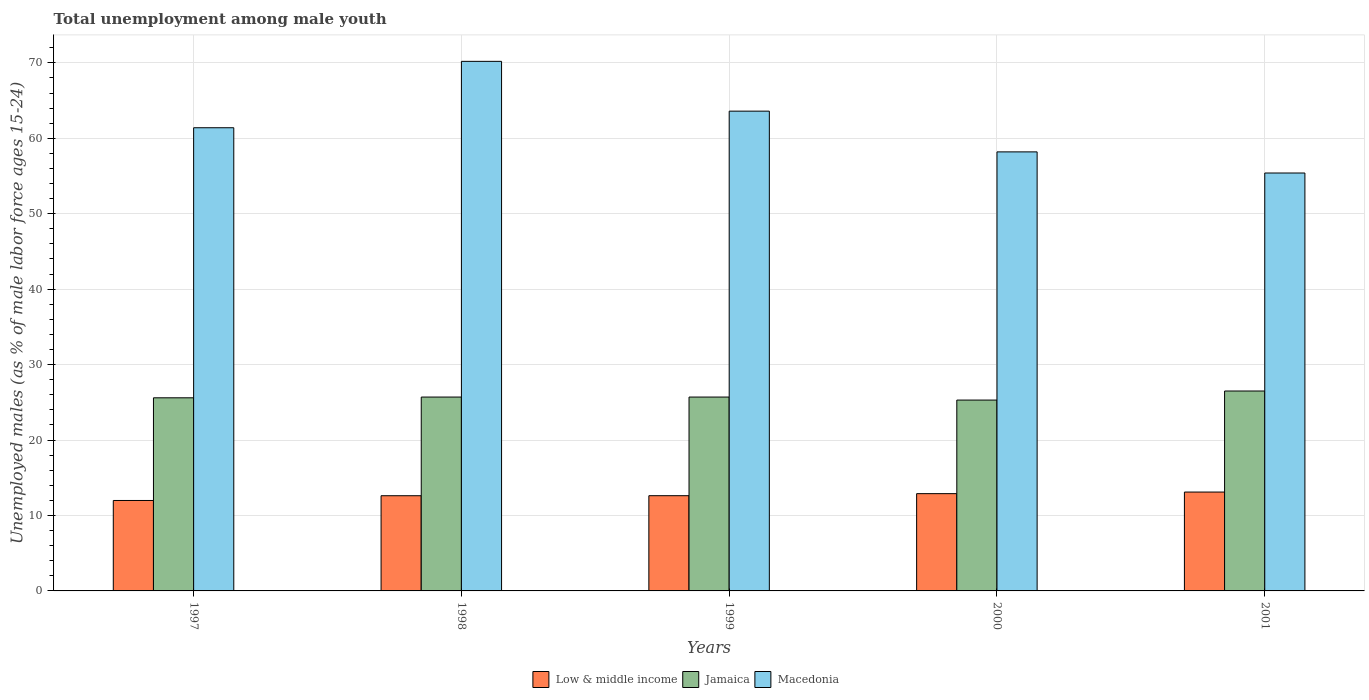How many groups of bars are there?
Keep it short and to the point. 5. Are the number of bars per tick equal to the number of legend labels?
Offer a very short reply. Yes. Are the number of bars on each tick of the X-axis equal?
Provide a short and direct response. Yes. How many bars are there on the 1st tick from the right?
Keep it short and to the point. 3. What is the label of the 3rd group of bars from the left?
Ensure brevity in your answer.  1999. What is the percentage of unemployed males in in Jamaica in 1998?
Your answer should be compact. 25.7. Across all years, what is the maximum percentage of unemployed males in in Low & middle income?
Your answer should be very brief. 13.11. Across all years, what is the minimum percentage of unemployed males in in Macedonia?
Make the answer very short. 55.4. In which year was the percentage of unemployed males in in Jamaica maximum?
Make the answer very short. 2001. What is the total percentage of unemployed males in in Low & middle income in the graph?
Your answer should be compact. 63.23. What is the difference between the percentage of unemployed males in in Low & middle income in 1999 and that in 2001?
Make the answer very short. -0.48. What is the difference between the percentage of unemployed males in in Jamaica in 1997 and the percentage of unemployed males in in Low & middle income in 1999?
Your response must be concise. 12.98. What is the average percentage of unemployed males in in Macedonia per year?
Your answer should be compact. 61.76. In the year 2001, what is the difference between the percentage of unemployed males in in Macedonia and percentage of unemployed males in in Low & middle income?
Offer a terse response. 42.29. What is the ratio of the percentage of unemployed males in in Low & middle income in 1999 to that in 2000?
Make the answer very short. 0.98. Is the percentage of unemployed males in in Low & middle income in 1999 less than that in 2000?
Your response must be concise. Yes. Is the difference between the percentage of unemployed males in in Macedonia in 1999 and 2001 greater than the difference between the percentage of unemployed males in in Low & middle income in 1999 and 2001?
Provide a short and direct response. Yes. What is the difference between the highest and the second highest percentage of unemployed males in in Jamaica?
Give a very brief answer. 0.8. What is the difference between the highest and the lowest percentage of unemployed males in in Low & middle income?
Your answer should be very brief. 1.12. In how many years, is the percentage of unemployed males in in Macedonia greater than the average percentage of unemployed males in in Macedonia taken over all years?
Keep it short and to the point. 2. Is the sum of the percentage of unemployed males in in Macedonia in 1999 and 2001 greater than the maximum percentage of unemployed males in in Jamaica across all years?
Offer a terse response. Yes. What does the 2nd bar from the left in 2001 represents?
Offer a very short reply. Jamaica. What does the 3rd bar from the right in 2000 represents?
Your answer should be very brief. Low & middle income. How many bars are there?
Provide a succinct answer. 15. What is the difference between two consecutive major ticks on the Y-axis?
Make the answer very short. 10. Are the values on the major ticks of Y-axis written in scientific E-notation?
Keep it short and to the point. No. Does the graph contain grids?
Ensure brevity in your answer.  Yes. How many legend labels are there?
Give a very brief answer. 3. What is the title of the graph?
Offer a terse response. Total unemployment among male youth. Does "New Caledonia" appear as one of the legend labels in the graph?
Your answer should be compact. No. What is the label or title of the X-axis?
Provide a short and direct response. Years. What is the label or title of the Y-axis?
Provide a succinct answer. Unemployed males (as % of male labor force ages 15-24). What is the Unemployed males (as % of male labor force ages 15-24) of Low & middle income in 1997?
Give a very brief answer. 11.99. What is the Unemployed males (as % of male labor force ages 15-24) of Jamaica in 1997?
Offer a very short reply. 25.6. What is the Unemployed males (as % of male labor force ages 15-24) of Macedonia in 1997?
Your response must be concise. 61.4. What is the Unemployed males (as % of male labor force ages 15-24) of Low & middle income in 1998?
Give a very brief answer. 12.62. What is the Unemployed males (as % of male labor force ages 15-24) in Jamaica in 1998?
Keep it short and to the point. 25.7. What is the Unemployed males (as % of male labor force ages 15-24) in Macedonia in 1998?
Offer a terse response. 70.2. What is the Unemployed males (as % of male labor force ages 15-24) of Low & middle income in 1999?
Ensure brevity in your answer.  12.62. What is the Unemployed males (as % of male labor force ages 15-24) of Jamaica in 1999?
Offer a very short reply. 25.7. What is the Unemployed males (as % of male labor force ages 15-24) of Macedonia in 1999?
Ensure brevity in your answer.  63.6. What is the Unemployed males (as % of male labor force ages 15-24) of Low & middle income in 2000?
Your answer should be compact. 12.9. What is the Unemployed males (as % of male labor force ages 15-24) of Jamaica in 2000?
Provide a succinct answer. 25.3. What is the Unemployed males (as % of male labor force ages 15-24) in Macedonia in 2000?
Give a very brief answer. 58.2. What is the Unemployed males (as % of male labor force ages 15-24) of Low & middle income in 2001?
Provide a succinct answer. 13.11. What is the Unemployed males (as % of male labor force ages 15-24) of Jamaica in 2001?
Offer a terse response. 26.5. What is the Unemployed males (as % of male labor force ages 15-24) of Macedonia in 2001?
Ensure brevity in your answer.  55.4. Across all years, what is the maximum Unemployed males (as % of male labor force ages 15-24) in Low & middle income?
Offer a terse response. 13.11. Across all years, what is the maximum Unemployed males (as % of male labor force ages 15-24) in Macedonia?
Your answer should be compact. 70.2. Across all years, what is the minimum Unemployed males (as % of male labor force ages 15-24) in Low & middle income?
Your answer should be very brief. 11.99. Across all years, what is the minimum Unemployed males (as % of male labor force ages 15-24) in Jamaica?
Make the answer very short. 25.3. Across all years, what is the minimum Unemployed males (as % of male labor force ages 15-24) of Macedonia?
Keep it short and to the point. 55.4. What is the total Unemployed males (as % of male labor force ages 15-24) of Low & middle income in the graph?
Offer a very short reply. 63.23. What is the total Unemployed males (as % of male labor force ages 15-24) in Jamaica in the graph?
Your response must be concise. 128.8. What is the total Unemployed males (as % of male labor force ages 15-24) of Macedonia in the graph?
Your answer should be compact. 308.8. What is the difference between the Unemployed males (as % of male labor force ages 15-24) of Low & middle income in 1997 and that in 1998?
Provide a short and direct response. -0.63. What is the difference between the Unemployed males (as % of male labor force ages 15-24) in Jamaica in 1997 and that in 1998?
Give a very brief answer. -0.1. What is the difference between the Unemployed males (as % of male labor force ages 15-24) in Macedonia in 1997 and that in 1998?
Your answer should be compact. -8.8. What is the difference between the Unemployed males (as % of male labor force ages 15-24) of Low & middle income in 1997 and that in 1999?
Offer a terse response. -0.63. What is the difference between the Unemployed males (as % of male labor force ages 15-24) in Macedonia in 1997 and that in 1999?
Your answer should be very brief. -2.2. What is the difference between the Unemployed males (as % of male labor force ages 15-24) in Low & middle income in 1997 and that in 2000?
Your answer should be very brief. -0.91. What is the difference between the Unemployed males (as % of male labor force ages 15-24) of Jamaica in 1997 and that in 2000?
Provide a succinct answer. 0.3. What is the difference between the Unemployed males (as % of male labor force ages 15-24) in Low & middle income in 1997 and that in 2001?
Offer a terse response. -1.12. What is the difference between the Unemployed males (as % of male labor force ages 15-24) of Low & middle income in 1998 and that in 1999?
Your response must be concise. -0. What is the difference between the Unemployed males (as % of male labor force ages 15-24) in Jamaica in 1998 and that in 1999?
Make the answer very short. 0. What is the difference between the Unemployed males (as % of male labor force ages 15-24) in Macedonia in 1998 and that in 1999?
Keep it short and to the point. 6.6. What is the difference between the Unemployed males (as % of male labor force ages 15-24) of Low & middle income in 1998 and that in 2000?
Provide a succinct answer. -0.28. What is the difference between the Unemployed males (as % of male labor force ages 15-24) in Low & middle income in 1998 and that in 2001?
Ensure brevity in your answer.  -0.49. What is the difference between the Unemployed males (as % of male labor force ages 15-24) of Jamaica in 1998 and that in 2001?
Your response must be concise. -0.8. What is the difference between the Unemployed males (as % of male labor force ages 15-24) of Low & middle income in 1999 and that in 2000?
Give a very brief answer. -0.27. What is the difference between the Unemployed males (as % of male labor force ages 15-24) in Macedonia in 1999 and that in 2000?
Offer a very short reply. 5.4. What is the difference between the Unemployed males (as % of male labor force ages 15-24) of Low & middle income in 1999 and that in 2001?
Provide a short and direct response. -0.48. What is the difference between the Unemployed males (as % of male labor force ages 15-24) of Macedonia in 1999 and that in 2001?
Offer a very short reply. 8.2. What is the difference between the Unemployed males (as % of male labor force ages 15-24) in Low & middle income in 2000 and that in 2001?
Keep it short and to the point. -0.21. What is the difference between the Unemployed males (as % of male labor force ages 15-24) of Low & middle income in 1997 and the Unemployed males (as % of male labor force ages 15-24) of Jamaica in 1998?
Your response must be concise. -13.71. What is the difference between the Unemployed males (as % of male labor force ages 15-24) in Low & middle income in 1997 and the Unemployed males (as % of male labor force ages 15-24) in Macedonia in 1998?
Offer a very short reply. -58.21. What is the difference between the Unemployed males (as % of male labor force ages 15-24) of Jamaica in 1997 and the Unemployed males (as % of male labor force ages 15-24) of Macedonia in 1998?
Offer a terse response. -44.6. What is the difference between the Unemployed males (as % of male labor force ages 15-24) in Low & middle income in 1997 and the Unemployed males (as % of male labor force ages 15-24) in Jamaica in 1999?
Your response must be concise. -13.71. What is the difference between the Unemployed males (as % of male labor force ages 15-24) in Low & middle income in 1997 and the Unemployed males (as % of male labor force ages 15-24) in Macedonia in 1999?
Ensure brevity in your answer.  -51.61. What is the difference between the Unemployed males (as % of male labor force ages 15-24) of Jamaica in 1997 and the Unemployed males (as % of male labor force ages 15-24) of Macedonia in 1999?
Provide a succinct answer. -38. What is the difference between the Unemployed males (as % of male labor force ages 15-24) of Low & middle income in 1997 and the Unemployed males (as % of male labor force ages 15-24) of Jamaica in 2000?
Your response must be concise. -13.31. What is the difference between the Unemployed males (as % of male labor force ages 15-24) in Low & middle income in 1997 and the Unemployed males (as % of male labor force ages 15-24) in Macedonia in 2000?
Give a very brief answer. -46.21. What is the difference between the Unemployed males (as % of male labor force ages 15-24) of Jamaica in 1997 and the Unemployed males (as % of male labor force ages 15-24) of Macedonia in 2000?
Provide a short and direct response. -32.6. What is the difference between the Unemployed males (as % of male labor force ages 15-24) of Low & middle income in 1997 and the Unemployed males (as % of male labor force ages 15-24) of Jamaica in 2001?
Make the answer very short. -14.51. What is the difference between the Unemployed males (as % of male labor force ages 15-24) of Low & middle income in 1997 and the Unemployed males (as % of male labor force ages 15-24) of Macedonia in 2001?
Provide a succinct answer. -43.41. What is the difference between the Unemployed males (as % of male labor force ages 15-24) in Jamaica in 1997 and the Unemployed males (as % of male labor force ages 15-24) in Macedonia in 2001?
Offer a very short reply. -29.8. What is the difference between the Unemployed males (as % of male labor force ages 15-24) in Low & middle income in 1998 and the Unemployed males (as % of male labor force ages 15-24) in Jamaica in 1999?
Your answer should be very brief. -13.08. What is the difference between the Unemployed males (as % of male labor force ages 15-24) in Low & middle income in 1998 and the Unemployed males (as % of male labor force ages 15-24) in Macedonia in 1999?
Provide a short and direct response. -50.98. What is the difference between the Unemployed males (as % of male labor force ages 15-24) in Jamaica in 1998 and the Unemployed males (as % of male labor force ages 15-24) in Macedonia in 1999?
Provide a succinct answer. -37.9. What is the difference between the Unemployed males (as % of male labor force ages 15-24) of Low & middle income in 1998 and the Unemployed males (as % of male labor force ages 15-24) of Jamaica in 2000?
Give a very brief answer. -12.68. What is the difference between the Unemployed males (as % of male labor force ages 15-24) in Low & middle income in 1998 and the Unemployed males (as % of male labor force ages 15-24) in Macedonia in 2000?
Your response must be concise. -45.58. What is the difference between the Unemployed males (as % of male labor force ages 15-24) of Jamaica in 1998 and the Unemployed males (as % of male labor force ages 15-24) of Macedonia in 2000?
Ensure brevity in your answer.  -32.5. What is the difference between the Unemployed males (as % of male labor force ages 15-24) in Low & middle income in 1998 and the Unemployed males (as % of male labor force ages 15-24) in Jamaica in 2001?
Ensure brevity in your answer.  -13.88. What is the difference between the Unemployed males (as % of male labor force ages 15-24) in Low & middle income in 1998 and the Unemployed males (as % of male labor force ages 15-24) in Macedonia in 2001?
Provide a succinct answer. -42.78. What is the difference between the Unemployed males (as % of male labor force ages 15-24) of Jamaica in 1998 and the Unemployed males (as % of male labor force ages 15-24) of Macedonia in 2001?
Offer a very short reply. -29.7. What is the difference between the Unemployed males (as % of male labor force ages 15-24) of Low & middle income in 1999 and the Unemployed males (as % of male labor force ages 15-24) of Jamaica in 2000?
Your answer should be very brief. -12.68. What is the difference between the Unemployed males (as % of male labor force ages 15-24) of Low & middle income in 1999 and the Unemployed males (as % of male labor force ages 15-24) of Macedonia in 2000?
Provide a short and direct response. -45.58. What is the difference between the Unemployed males (as % of male labor force ages 15-24) of Jamaica in 1999 and the Unemployed males (as % of male labor force ages 15-24) of Macedonia in 2000?
Provide a succinct answer. -32.5. What is the difference between the Unemployed males (as % of male labor force ages 15-24) of Low & middle income in 1999 and the Unemployed males (as % of male labor force ages 15-24) of Jamaica in 2001?
Keep it short and to the point. -13.88. What is the difference between the Unemployed males (as % of male labor force ages 15-24) in Low & middle income in 1999 and the Unemployed males (as % of male labor force ages 15-24) in Macedonia in 2001?
Offer a terse response. -42.78. What is the difference between the Unemployed males (as % of male labor force ages 15-24) of Jamaica in 1999 and the Unemployed males (as % of male labor force ages 15-24) of Macedonia in 2001?
Provide a short and direct response. -29.7. What is the difference between the Unemployed males (as % of male labor force ages 15-24) in Low & middle income in 2000 and the Unemployed males (as % of male labor force ages 15-24) in Jamaica in 2001?
Your response must be concise. -13.6. What is the difference between the Unemployed males (as % of male labor force ages 15-24) in Low & middle income in 2000 and the Unemployed males (as % of male labor force ages 15-24) in Macedonia in 2001?
Give a very brief answer. -42.5. What is the difference between the Unemployed males (as % of male labor force ages 15-24) of Jamaica in 2000 and the Unemployed males (as % of male labor force ages 15-24) of Macedonia in 2001?
Provide a succinct answer. -30.1. What is the average Unemployed males (as % of male labor force ages 15-24) in Low & middle income per year?
Keep it short and to the point. 12.65. What is the average Unemployed males (as % of male labor force ages 15-24) in Jamaica per year?
Provide a succinct answer. 25.76. What is the average Unemployed males (as % of male labor force ages 15-24) of Macedonia per year?
Provide a short and direct response. 61.76. In the year 1997, what is the difference between the Unemployed males (as % of male labor force ages 15-24) of Low & middle income and Unemployed males (as % of male labor force ages 15-24) of Jamaica?
Offer a terse response. -13.61. In the year 1997, what is the difference between the Unemployed males (as % of male labor force ages 15-24) in Low & middle income and Unemployed males (as % of male labor force ages 15-24) in Macedonia?
Ensure brevity in your answer.  -49.41. In the year 1997, what is the difference between the Unemployed males (as % of male labor force ages 15-24) in Jamaica and Unemployed males (as % of male labor force ages 15-24) in Macedonia?
Keep it short and to the point. -35.8. In the year 1998, what is the difference between the Unemployed males (as % of male labor force ages 15-24) of Low & middle income and Unemployed males (as % of male labor force ages 15-24) of Jamaica?
Offer a very short reply. -13.08. In the year 1998, what is the difference between the Unemployed males (as % of male labor force ages 15-24) in Low & middle income and Unemployed males (as % of male labor force ages 15-24) in Macedonia?
Offer a very short reply. -57.58. In the year 1998, what is the difference between the Unemployed males (as % of male labor force ages 15-24) in Jamaica and Unemployed males (as % of male labor force ages 15-24) in Macedonia?
Your response must be concise. -44.5. In the year 1999, what is the difference between the Unemployed males (as % of male labor force ages 15-24) in Low & middle income and Unemployed males (as % of male labor force ages 15-24) in Jamaica?
Keep it short and to the point. -13.08. In the year 1999, what is the difference between the Unemployed males (as % of male labor force ages 15-24) in Low & middle income and Unemployed males (as % of male labor force ages 15-24) in Macedonia?
Give a very brief answer. -50.98. In the year 1999, what is the difference between the Unemployed males (as % of male labor force ages 15-24) in Jamaica and Unemployed males (as % of male labor force ages 15-24) in Macedonia?
Offer a terse response. -37.9. In the year 2000, what is the difference between the Unemployed males (as % of male labor force ages 15-24) in Low & middle income and Unemployed males (as % of male labor force ages 15-24) in Jamaica?
Provide a succinct answer. -12.4. In the year 2000, what is the difference between the Unemployed males (as % of male labor force ages 15-24) in Low & middle income and Unemployed males (as % of male labor force ages 15-24) in Macedonia?
Offer a terse response. -45.3. In the year 2000, what is the difference between the Unemployed males (as % of male labor force ages 15-24) in Jamaica and Unemployed males (as % of male labor force ages 15-24) in Macedonia?
Provide a succinct answer. -32.9. In the year 2001, what is the difference between the Unemployed males (as % of male labor force ages 15-24) of Low & middle income and Unemployed males (as % of male labor force ages 15-24) of Jamaica?
Provide a short and direct response. -13.39. In the year 2001, what is the difference between the Unemployed males (as % of male labor force ages 15-24) of Low & middle income and Unemployed males (as % of male labor force ages 15-24) of Macedonia?
Give a very brief answer. -42.29. In the year 2001, what is the difference between the Unemployed males (as % of male labor force ages 15-24) in Jamaica and Unemployed males (as % of male labor force ages 15-24) in Macedonia?
Provide a short and direct response. -28.9. What is the ratio of the Unemployed males (as % of male labor force ages 15-24) in Low & middle income in 1997 to that in 1998?
Your answer should be compact. 0.95. What is the ratio of the Unemployed males (as % of male labor force ages 15-24) of Jamaica in 1997 to that in 1998?
Ensure brevity in your answer.  1. What is the ratio of the Unemployed males (as % of male labor force ages 15-24) of Macedonia in 1997 to that in 1998?
Give a very brief answer. 0.87. What is the ratio of the Unemployed males (as % of male labor force ages 15-24) of Low & middle income in 1997 to that in 1999?
Ensure brevity in your answer.  0.95. What is the ratio of the Unemployed males (as % of male labor force ages 15-24) in Jamaica in 1997 to that in 1999?
Keep it short and to the point. 1. What is the ratio of the Unemployed males (as % of male labor force ages 15-24) in Macedonia in 1997 to that in 1999?
Your answer should be compact. 0.97. What is the ratio of the Unemployed males (as % of male labor force ages 15-24) of Low & middle income in 1997 to that in 2000?
Provide a succinct answer. 0.93. What is the ratio of the Unemployed males (as % of male labor force ages 15-24) in Jamaica in 1997 to that in 2000?
Offer a terse response. 1.01. What is the ratio of the Unemployed males (as % of male labor force ages 15-24) in Macedonia in 1997 to that in 2000?
Make the answer very short. 1.05. What is the ratio of the Unemployed males (as % of male labor force ages 15-24) in Low & middle income in 1997 to that in 2001?
Your answer should be very brief. 0.91. What is the ratio of the Unemployed males (as % of male labor force ages 15-24) in Jamaica in 1997 to that in 2001?
Ensure brevity in your answer.  0.97. What is the ratio of the Unemployed males (as % of male labor force ages 15-24) in Macedonia in 1997 to that in 2001?
Provide a succinct answer. 1.11. What is the ratio of the Unemployed males (as % of male labor force ages 15-24) of Low & middle income in 1998 to that in 1999?
Make the answer very short. 1. What is the ratio of the Unemployed males (as % of male labor force ages 15-24) of Macedonia in 1998 to that in 1999?
Make the answer very short. 1.1. What is the ratio of the Unemployed males (as % of male labor force ages 15-24) in Low & middle income in 1998 to that in 2000?
Offer a very short reply. 0.98. What is the ratio of the Unemployed males (as % of male labor force ages 15-24) of Jamaica in 1998 to that in 2000?
Keep it short and to the point. 1.02. What is the ratio of the Unemployed males (as % of male labor force ages 15-24) in Macedonia in 1998 to that in 2000?
Offer a terse response. 1.21. What is the ratio of the Unemployed males (as % of male labor force ages 15-24) of Low & middle income in 1998 to that in 2001?
Keep it short and to the point. 0.96. What is the ratio of the Unemployed males (as % of male labor force ages 15-24) of Jamaica in 1998 to that in 2001?
Offer a terse response. 0.97. What is the ratio of the Unemployed males (as % of male labor force ages 15-24) of Macedonia in 1998 to that in 2001?
Your answer should be compact. 1.27. What is the ratio of the Unemployed males (as % of male labor force ages 15-24) of Low & middle income in 1999 to that in 2000?
Your answer should be very brief. 0.98. What is the ratio of the Unemployed males (as % of male labor force ages 15-24) in Jamaica in 1999 to that in 2000?
Your response must be concise. 1.02. What is the ratio of the Unemployed males (as % of male labor force ages 15-24) in Macedonia in 1999 to that in 2000?
Your response must be concise. 1.09. What is the ratio of the Unemployed males (as % of male labor force ages 15-24) in Low & middle income in 1999 to that in 2001?
Ensure brevity in your answer.  0.96. What is the ratio of the Unemployed males (as % of male labor force ages 15-24) in Jamaica in 1999 to that in 2001?
Provide a succinct answer. 0.97. What is the ratio of the Unemployed males (as % of male labor force ages 15-24) in Macedonia in 1999 to that in 2001?
Offer a terse response. 1.15. What is the ratio of the Unemployed males (as % of male labor force ages 15-24) of Low & middle income in 2000 to that in 2001?
Give a very brief answer. 0.98. What is the ratio of the Unemployed males (as % of male labor force ages 15-24) of Jamaica in 2000 to that in 2001?
Your answer should be very brief. 0.95. What is the ratio of the Unemployed males (as % of male labor force ages 15-24) in Macedonia in 2000 to that in 2001?
Provide a succinct answer. 1.05. What is the difference between the highest and the second highest Unemployed males (as % of male labor force ages 15-24) in Low & middle income?
Offer a terse response. 0.21. What is the difference between the highest and the second highest Unemployed males (as % of male labor force ages 15-24) in Jamaica?
Provide a succinct answer. 0.8. What is the difference between the highest and the lowest Unemployed males (as % of male labor force ages 15-24) of Low & middle income?
Make the answer very short. 1.12. What is the difference between the highest and the lowest Unemployed males (as % of male labor force ages 15-24) of Jamaica?
Ensure brevity in your answer.  1.2. 